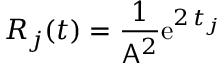Convert formula to latex. <formula><loc_0><loc_0><loc_500><loc_500>R _ { j } ( t ) = \frac { 1 } { A ^ { 2 } } e ^ { 2 \, t _ { j } }</formula> 